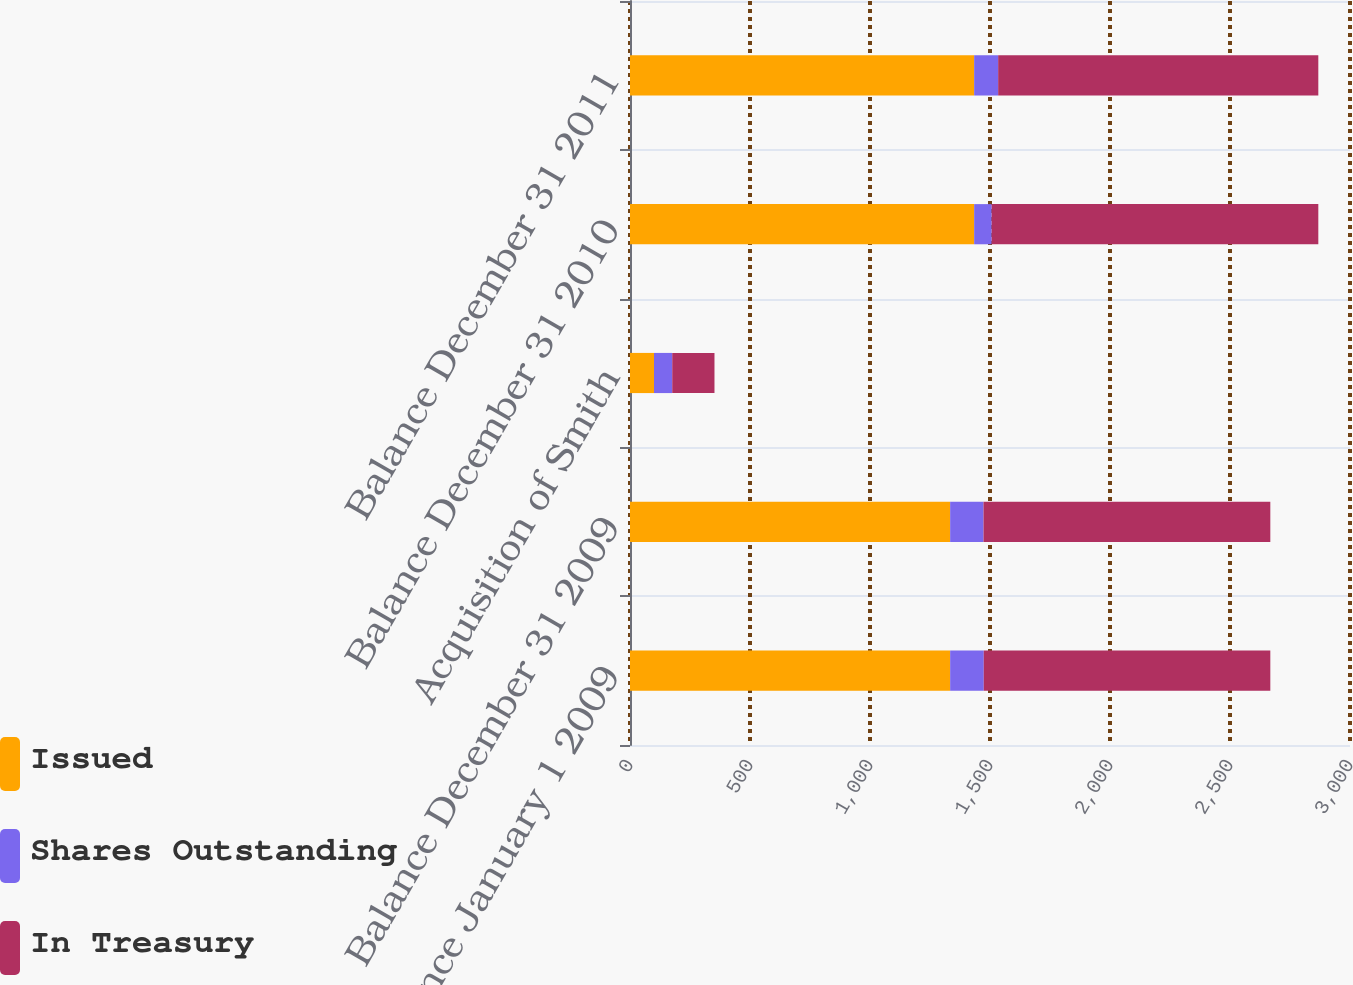Convert chart to OTSL. <chart><loc_0><loc_0><loc_500><loc_500><stacked_bar_chart><ecel><fcel>Balance January 1 2009<fcel>Balance December 31 2009<fcel>Acquisition of Smith<fcel>Balance December 31 2010<fcel>Balance December 31 2011<nl><fcel>Issued<fcel>1334<fcel>1334<fcel>100<fcel>1434<fcel>1434<nl><fcel>Shares Outstanding<fcel>140<fcel>139<fcel>76<fcel>73<fcel>100<nl><fcel>In Treasury<fcel>1194<fcel>1195<fcel>176<fcel>1361<fcel>1334<nl></chart> 